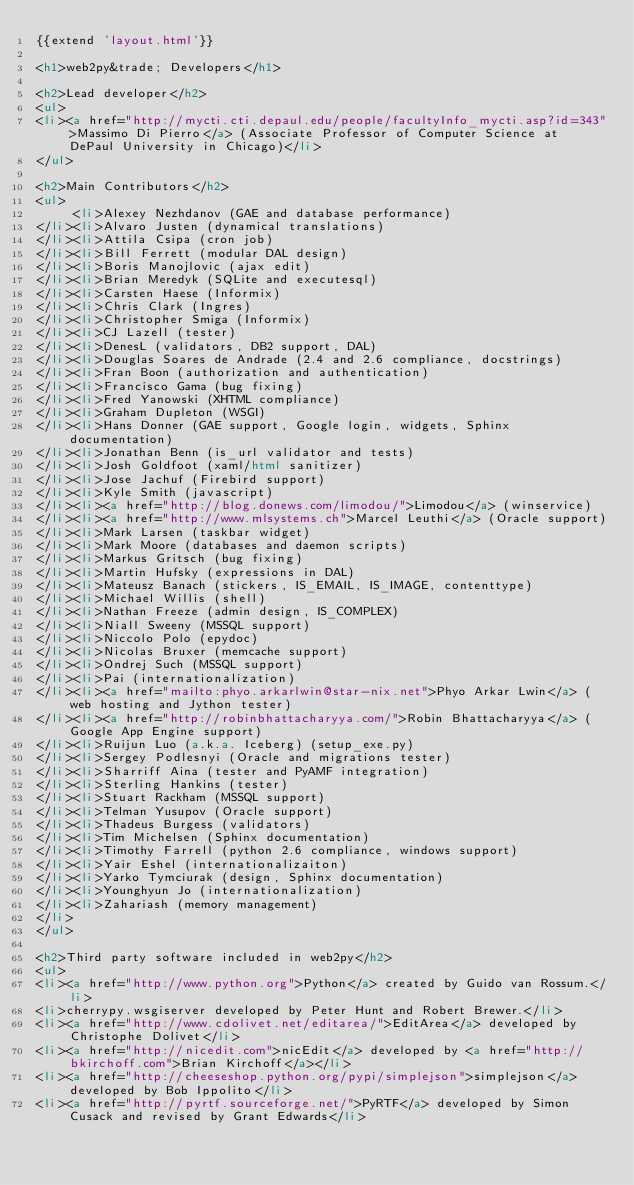<code> <loc_0><loc_0><loc_500><loc_500><_HTML_>{{extend 'layout.html'}}

<h1>web2py&trade; Developers</h1>

<h2>Lead developer</h2>
<ul>
<li><a href="http://mycti.cti.depaul.edu/people/facultyInfo_mycti.asp?id=343">Massimo Di Pierro</a> (Associate Professor of Computer Science at DePaul University in Chicago)</li>
</ul>

<h2>Main Contributors</h2>
<ul>
     <li>Alexey Nezhdanov (GAE and database performance)
</li><li>Alvaro Justen (dynamical translations)
</li><li>Attila Csipa (cron job)
</li><li>Bill Ferrett (modular DAL design)
</li><li>Boris Manojlovic (ajax edit) 
</li><li>Brian Meredyk (SQLite and executesql)
</li><li>Carsten Haese (Informix)
</li><li>Chris Clark (Ingres)
</li><li>Christopher Smiga (Informix)
</li><li>CJ Lazell (tester)
</li><li>DenesL (validators, DB2 support, DAL)
</li><li>Douglas Soares de Andrade (2.4 and 2.6 compliance, docstrings)
</li><li>Fran Boon (authorization and authentication)
</li><li>Francisco Gama (bug fixing)
</li><li>Fred Yanowski (XHTML compliance)
</li><li>Graham Dupleton (WSGI)
</li><li>Hans Donner (GAE support, Google login, widgets, Sphinx documentation)
</li><li>Jonathan Benn (is_url validator and tests)
</li><li>Josh Goldfoot (xaml/html sanitizer)
</li><li>Jose Jachuf (Firebird support)
</li><li>Kyle Smith (javascript)
</li><li><a href="http://blog.donews.com/limodou/">Limodou</a> (winservice)
</li><li><a href="http://www.mlsystems.ch">Marcel Leuthi</a> (Oracle support)
</li><li>Mark Larsen (taskbar widget)
</li><li>Mark Moore (databases and daemon scripts)
</li><li>Markus Gritsch (bug fixing)
</li><li>Martin Hufsky (expressions in DAL)
</li><li>Mateusz Banach (stickers, IS_EMAIL, IS_IMAGE, contenttype)
</li><li>Michael Willis (shell)
</li><li>Nathan Freeze (admin design, IS_COMPLEX)
</li><li>Niall Sweeny (MSSQL support)
</li><li>Niccolo Polo (epydoc)
</li><li>Nicolas Bruxer (memcache support)
</li><li>Ondrej Such (MSSQL support)
</li><li>Pai (internationalization)
</li><li><a href="mailto:phyo.arkarlwin@star-nix.net">Phyo Arkar Lwin</a> (web hosting and Jython tester)
</li><li><a href="http://robinbhattacharyya.com/">Robin Bhattacharyya</a> (Google App Engine support)
</li><li>Ruijun Luo (a.k.a. Iceberg) (setup_exe.py)
</li><li>Sergey Podlesnyi (Oracle and migrations tester)
</li><li>Sharriff Aina (tester and PyAMF integration)
</li><li>Sterling Hankins (tester)
</li><li>Stuart Rackham (MSSQL support)
</li><li>Telman Yusupov (Oracle support)
</li><li>Thadeus Burgess (validators)
</li><li>Tim Michelsen (Sphinx documentation)
</li><li>Timothy Farrell (python 2.6 compliance, windows support)
</li><li>Yair Eshel (internationalizaiton)
</li><li>Yarko Tymciurak (design, Sphinx documentation)
</li><li>Younghyun Jo (internationalization)
</li><li>Zahariash (memory management)
</li>
</ul>

<h2>Third party software included in web2py</h2>
<ul>
<li><a href="http://www.python.org">Python</a> created by Guido van Rossum.</li>
<li>cherrypy.wsgiserver developed by Peter Hunt and Robert Brewer.</li>
<li><a href="http://www.cdolivet.net/editarea/">EditArea</a> developed by Christophe Dolivet</li>
<li><a href="http://nicedit.com">nicEdit</a> developed by <a href="http://bkirchoff.com">Brian Kirchoff</a></li>
<li><a href="http://cheeseshop.python.org/pypi/simplejson">simplejson</a> developed by Bob Ippolito</li>
<li><a href="http://pyrtf.sourceforge.net/">PyRTF</a> developed by Simon Cusack and revised by Grant Edwards</li></code> 